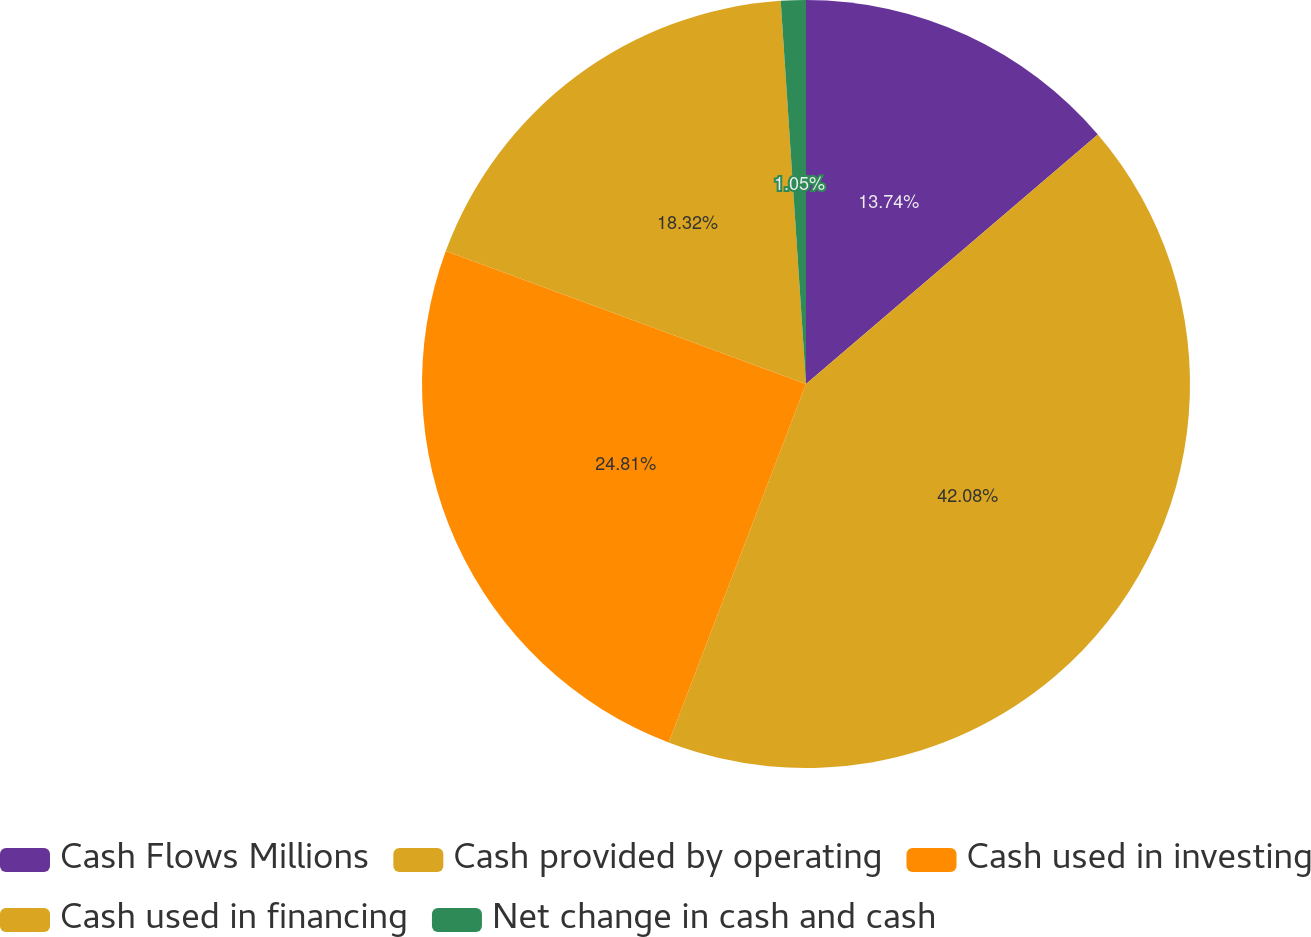Convert chart to OTSL. <chart><loc_0><loc_0><loc_500><loc_500><pie_chart><fcel>Cash Flows Millions<fcel>Cash provided by operating<fcel>Cash used in investing<fcel>Cash used in financing<fcel>Net change in cash and cash<nl><fcel>13.74%<fcel>42.08%<fcel>24.81%<fcel>18.32%<fcel>1.05%<nl></chart> 